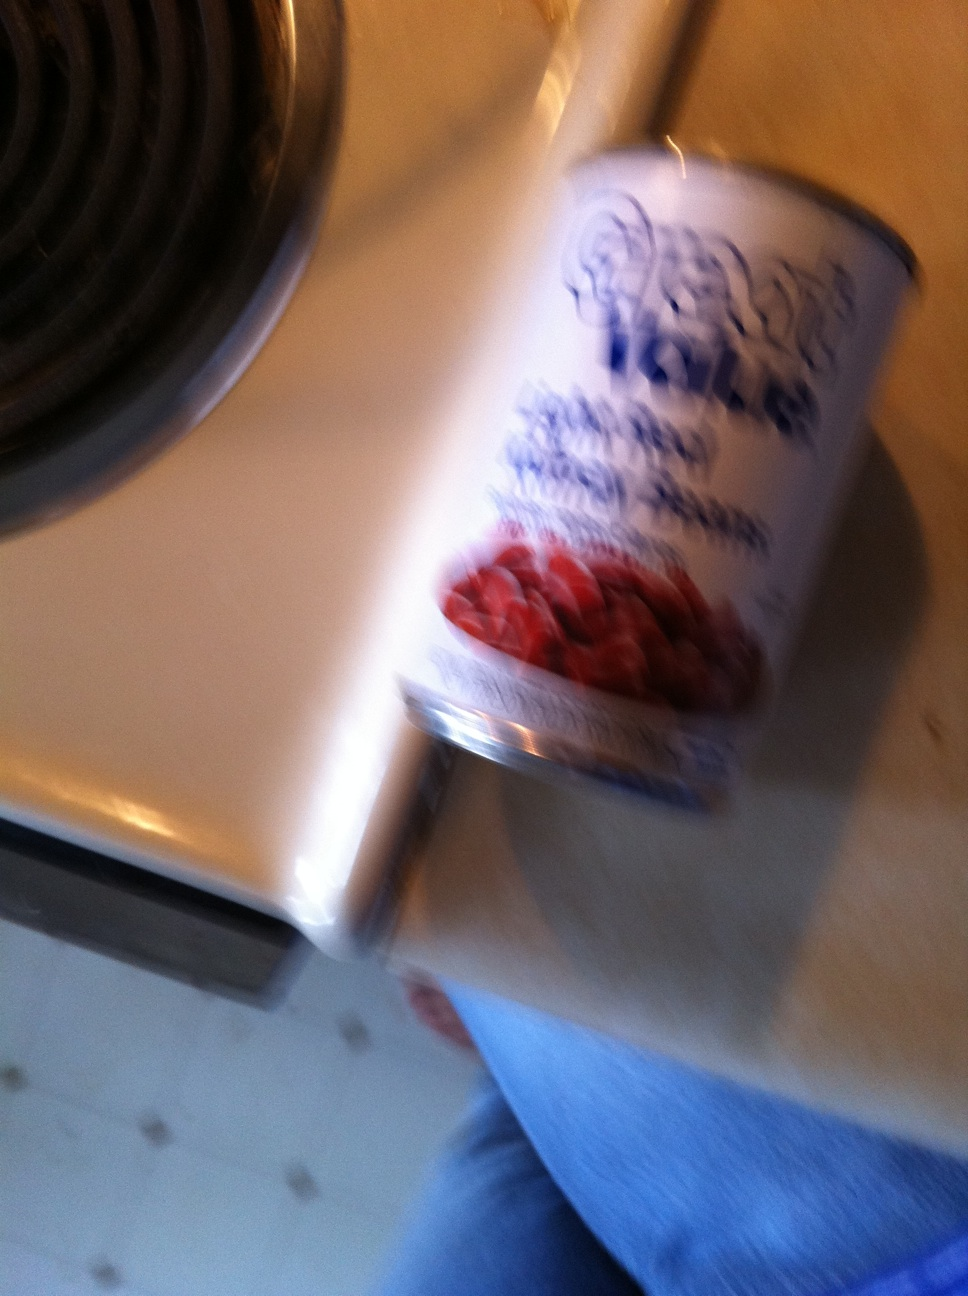What is in this can? The can appears to contain beans, based on the visible label, although the image is blurry making the details hard to discern. 